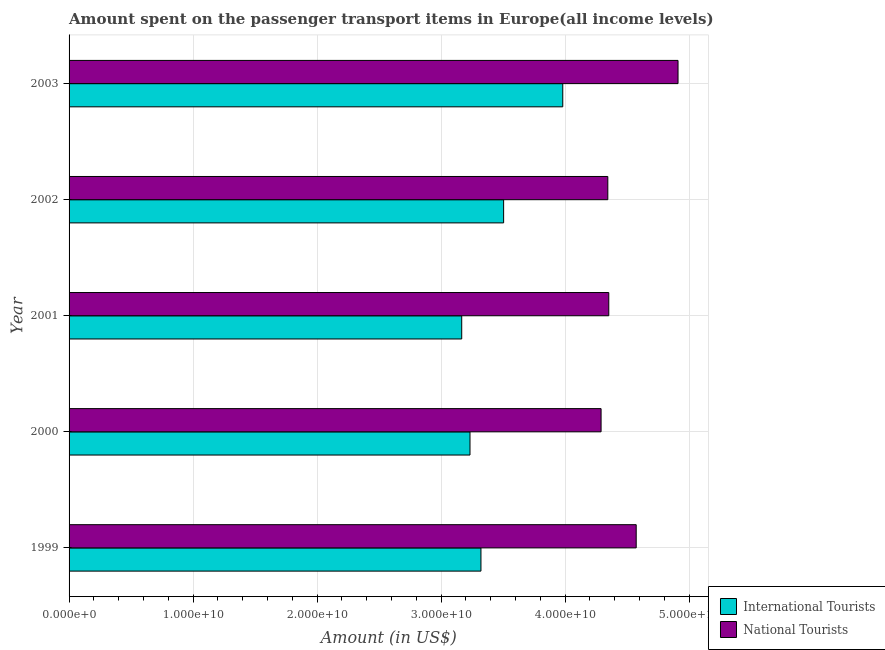How many different coloured bars are there?
Provide a succinct answer. 2. How many groups of bars are there?
Give a very brief answer. 5. Are the number of bars per tick equal to the number of legend labels?
Make the answer very short. Yes. What is the amount spent on transport items of national tourists in 1999?
Ensure brevity in your answer.  4.57e+1. Across all years, what is the maximum amount spent on transport items of national tourists?
Give a very brief answer. 4.91e+1. Across all years, what is the minimum amount spent on transport items of international tourists?
Ensure brevity in your answer.  3.17e+1. What is the total amount spent on transport items of international tourists in the graph?
Offer a very short reply. 1.72e+11. What is the difference between the amount spent on transport items of national tourists in 2000 and that in 2001?
Give a very brief answer. -6.21e+08. What is the difference between the amount spent on transport items of international tourists in 2000 and the amount spent on transport items of national tourists in 2001?
Make the answer very short. -1.12e+1. What is the average amount spent on transport items of international tourists per year?
Keep it short and to the point. 3.44e+1. In the year 2001, what is the difference between the amount spent on transport items of national tourists and amount spent on transport items of international tourists?
Provide a succinct answer. 1.19e+1. In how many years, is the amount spent on transport items of national tourists greater than 2000000000 US$?
Ensure brevity in your answer.  5. What is the ratio of the amount spent on transport items of national tourists in 1999 to that in 2003?
Keep it short and to the point. 0.93. Is the difference between the amount spent on transport items of national tourists in 2000 and 2002 greater than the difference between the amount spent on transport items of international tourists in 2000 and 2002?
Give a very brief answer. Yes. What is the difference between the highest and the second highest amount spent on transport items of international tourists?
Offer a terse response. 4.77e+09. What is the difference between the highest and the lowest amount spent on transport items of international tourists?
Ensure brevity in your answer.  8.15e+09. In how many years, is the amount spent on transport items of national tourists greater than the average amount spent on transport items of national tourists taken over all years?
Ensure brevity in your answer.  2. Is the sum of the amount spent on transport items of national tourists in 2000 and 2003 greater than the maximum amount spent on transport items of international tourists across all years?
Give a very brief answer. Yes. What does the 2nd bar from the top in 2000 represents?
Give a very brief answer. International Tourists. What does the 1st bar from the bottom in 1999 represents?
Ensure brevity in your answer.  International Tourists. What is the difference between two consecutive major ticks on the X-axis?
Make the answer very short. 1.00e+1. Does the graph contain any zero values?
Keep it short and to the point. No. Does the graph contain grids?
Provide a succinct answer. Yes. How are the legend labels stacked?
Make the answer very short. Vertical. What is the title of the graph?
Your response must be concise. Amount spent on the passenger transport items in Europe(all income levels). Does "Resident workers" appear as one of the legend labels in the graph?
Make the answer very short. No. What is the label or title of the Y-axis?
Offer a terse response. Year. What is the Amount (in US$) of International Tourists in 1999?
Keep it short and to the point. 3.32e+1. What is the Amount (in US$) in National Tourists in 1999?
Offer a terse response. 4.57e+1. What is the Amount (in US$) in International Tourists in 2000?
Your answer should be compact. 3.23e+1. What is the Amount (in US$) of National Tourists in 2000?
Keep it short and to the point. 4.29e+1. What is the Amount (in US$) in International Tourists in 2001?
Your answer should be compact. 3.17e+1. What is the Amount (in US$) in National Tourists in 2001?
Your response must be concise. 4.35e+1. What is the Amount (in US$) of International Tourists in 2002?
Your answer should be compact. 3.50e+1. What is the Amount (in US$) of National Tourists in 2002?
Offer a terse response. 4.34e+1. What is the Amount (in US$) in International Tourists in 2003?
Provide a short and direct response. 3.98e+1. What is the Amount (in US$) in National Tourists in 2003?
Give a very brief answer. 4.91e+1. Across all years, what is the maximum Amount (in US$) of International Tourists?
Provide a succinct answer. 3.98e+1. Across all years, what is the maximum Amount (in US$) in National Tourists?
Your response must be concise. 4.91e+1. Across all years, what is the minimum Amount (in US$) of International Tourists?
Ensure brevity in your answer.  3.17e+1. Across all years, what is the minimum Amount (in US$) of National Tourists?
Your answer should be compact. 4.29e+1. What is the total Amount (in US$) in International Tourists in the graph?
Offer a terse response. 1.72e+11. What is the total Amount (in US$) in National Tourists in the graph?
Your answer should be very brief. 2.25e+11. What is the difference between the Amount (in US$) of International Tourists in 1999 and that in 2000?
Give a very brief answer. 8.83e+08. What is the difference between the Amount (in US$) of National Tourists in 1999 and that in 2000?
Offer a very short reply. 2.83e+09. What is the difference between the Amount (in US$) in International Tourists in 1999 and that in 2001?
Keep it short and to the point. 1.55e+09. What is the difference between the Amount (in US$) of National Tourists in 1999 and that in 2001?
Your answer should be compact. 2.21e+09. What is the difference between the Amount (in US$) in International Tourists in 1999 and that in 2002?
Offer a terse response. -1.83e+09. What is the difference between the Amount (in US$) in National Tourists in 1999 and that in 2002?
Your response must be concise. 2.29e+09. What is the difference between the Amount (in US$) of International Tourists in 1999 and that in 2003?
Make the answer very short. -6.60e+09. What is the difference between the Amount (in US$) in National Tourists in 1999 and that in 2003?
Keep it short and to the point. -3.37e+09. What is the difference between the Amount (in US$) of International Tourists in 2000 and that in 2001?
Your response must be concise. 6.68e+08. What is the difference between the Amount (in US$) in National Tourists in 2000 and that in 2001?
Your answer should be compact. -6.21e+08. What is the difference between the Amount (in US$) of International Tourists in 2000 and that in 2002?
Make the answer very short. -2.71e+09. What is the difference between the Amount (in US$) of National Tourists in 2000 and that in 2002?
Make the answer very short. -5.42e+08. What is the difference between the Amount (in US$) of International Tourists in 2000 and that in 2003?
Provide a short and direct response. -7.48e+09. What is the difference between the Amount (in US$) of National Tourists in 2000 and that in 2003?
Offer a very short reply. -6.21e+09. What is the difference between the Amount (in US$) of International Tourists in 2001 and that in 2002?
Your answer should be very brief. -3.38e+09. What is the difference between the Amount (in US$) in National Tourists in 2001 and that in 2002?
Your answer should be very brief. 7.86e+07. What is the difference between the Amount (in US$) of International Tourists in 2001 and that in 2003?
Your answer should be compact. -8.15e+09. What is the difference between the Amount (in US$) of National Tourists in 2001 and that in 2003?
Provide a succinct answer. -5.58e+09. What is the difference between the Amount (in US$) in International Tourists in 2002 and that in 2003?
Make the answer very short. -4.77e+09. What is the difference between the Amount (in US$) in National Tourists in 2002 and that in 2003?
Give a very brief answer. -5.66e+09. What is the difference between the Amount (in US$) in International Tourists in 1999 and the Amount (in US$) in National Tourists in 2000?
Provide a short and direct response. -9.69e+09. What is the difference between the Amount (in US$) of International Tourists in 1999 and the Amount (in US$) of National Tourists in 2001?
Provide a succinct answer. -1.03e+1. What is the difference between the Amount (in US$) in International Tourists in 1999 and the Amount (in US$) in National Tourists in 2002?
Give a very brief answer. -1.02e+1. What is the difference between the Amount (in US$) in International Tourists in 1999 and the Amount (in US$) in National Tourists in 2003?
Offer a terse response. -1.59e+1. What is the difference between the Amount (in US$) of International Tourists in 2000 and the Amount (in US$) of National Tourists in 2001?
Your answer should be very brief. -1.12e+1. What is the difference between the Amount (in US$) of International Tourists in 2000 and the Amount (in US$) of National Tourists in 2002?
Your answer should be compact. -1.11e+1. What is the difference between the Amount (in US$) in International Tourists in 2000 and the Amount (in US$) in National Tourists in 2003?
Your answer should be compact. -1.68e+1. What is the difference between the Amount (in US$) in International Tourists in 2001 and the Amount (in US$) in National Tourists in 2002?
Offer a terse response. -1.18e+1. What is the difference between the Amount (in US$) of International Tourists in 2001 and the Amount (in US$) of National Tourists in 2003?
Make the answer very short. -1.74e+1. What is the difference between the Amount (in US$) in International Tourists in 2002 and the Amount (in US$) in National Tourists in 2003?
Keep it short and to the point. -1.41e+1. What is the average Amount (in US$) of International Tourists per year?
Ensure brevity in your answer.  3.44e+1. What is the average Amount (in US$) in National Tourists per year?
Ensure brevity in your answer.  4.49e+1. In the year 1999, what is the difference between the Amount (in US$) of International Tourists and Amount (in US$) of National Tourists?
Provide a succinct answer. -1.25e+1. In the year 2000, what is the difference between the Amount (in US$) of International Tourists and Amount (in US$) of National Tourists?
Your response must be concise. -1.06e+1. In the year 2001, what is the difference between the Amount (in US$) of International Tourists and Amount (in US$) of National Tourists?
Give a very brief answer. -1.19e+1. In the year 2002, what is the difference between the Amount (in US$) in International Tourists and Amount (in US$) in National Tourists?
Ensure brevity in your answer.  -8.40e+09. In the year 2003, what is the difference between the Amount (in US$) of International Tourists and Amount (in US$) of National Tourists?
Your answer should be compact. -9.29e+09. What is the ratio of the Amount (in US$) of International Tourists in 1999 to that in 2000?
Your answer should be very brief. 1.03. What is the ratio of the Amount (in US$) of National Tourists in 1999 to that in 2000?
Provide a succinct answer. 1.07. What is the ratio of the Amount (in US$) in International Tourists in 1999 to that in 2001?
Give a very brief answer. 1.05. What is the ratio of the Amount (in US$) in National Tourists in 1999 to that in 2001?
Your response must be concise. 1.05. What is the ratio of the Amount (in US$) of International Tourists in 1999 to that in 2002?
Your answer should be very brief. 0.95. What is the ratio of the Amount (in US$) in National Tourists in 1999 to that in 2002?
Make the answer very short. 1.05. What is the ratio of the Amount (in US$) in International Tourists in 1999 to that in 2003?
Keep it short and to the point. 0.83. What is the ratio of the Amount (in US$) in National Tourists in 1999 to that in 2003?
Provide a short and direct response. 0.93. What is the ratio of the Amount (in US$) of International Tourists in 2000 to that in 2001?
Keep it short and to the point. 1.02. What is the ratio of the Amount (in US$) in National Tourists in 2000 to that in 2001?
Offer a very short reply. 0.99. What is the ratio of the Amount (in US$) in International Tourists in 2000 to that in 2002?
Make the answer very short. 0.92. What is the ratio of the Amount (in US$) of National Tourists in 2000 to that in 2002?
Your response must be concise. 0.99. What is the ratio of the Amount (in US$) of International Tourists in 2000 to that in 2003?
Ensure brevity in your answer.  0.81. What is the ratio of the Amount (in US$) in National Tourists in 2000 to that in 2003?
Offer a very short reply. 0.87. What is the ratio of the Amount (in US$) in International Tourists in 2001 to that in 2002?
Give a very brief answer. 0.9. What is the ratio of the Amount (in US$) of International Tourists in 2001 to that in 2003?
Offer a very short reply. 0.8. What is the ratio of the Amount (in US$) in National Tourists in 2001 to that in 2003?
Your response must be concise. 0.89. What is the ratio of the Amount (in US$) of International Tourists in 2002 to that in 2003?
Your response must be concise. 0.88. What is the ratio of the Amount (in US$) of National Tourists in 2002 to that in 2003?
Give a very brief answer. 0.88. What is the difference between the highest and the second highest Amount (in US$) of International Tourists?
Give a very brief answer. 4.77e+09. What is the difference between the highest and the second highest Amount (in US$) in National Tourists?
Ensure brevity in your answer.  3.37e+09. What is the difference between the highest and the lowest Amount (in US$) in International Tourists?
Your answer should be very brief. 8.15e+09. What is the difference between the highest and the lowest Amount (in US$) in National Tourists?
Keep it short and to the point. 6.21e+09. 